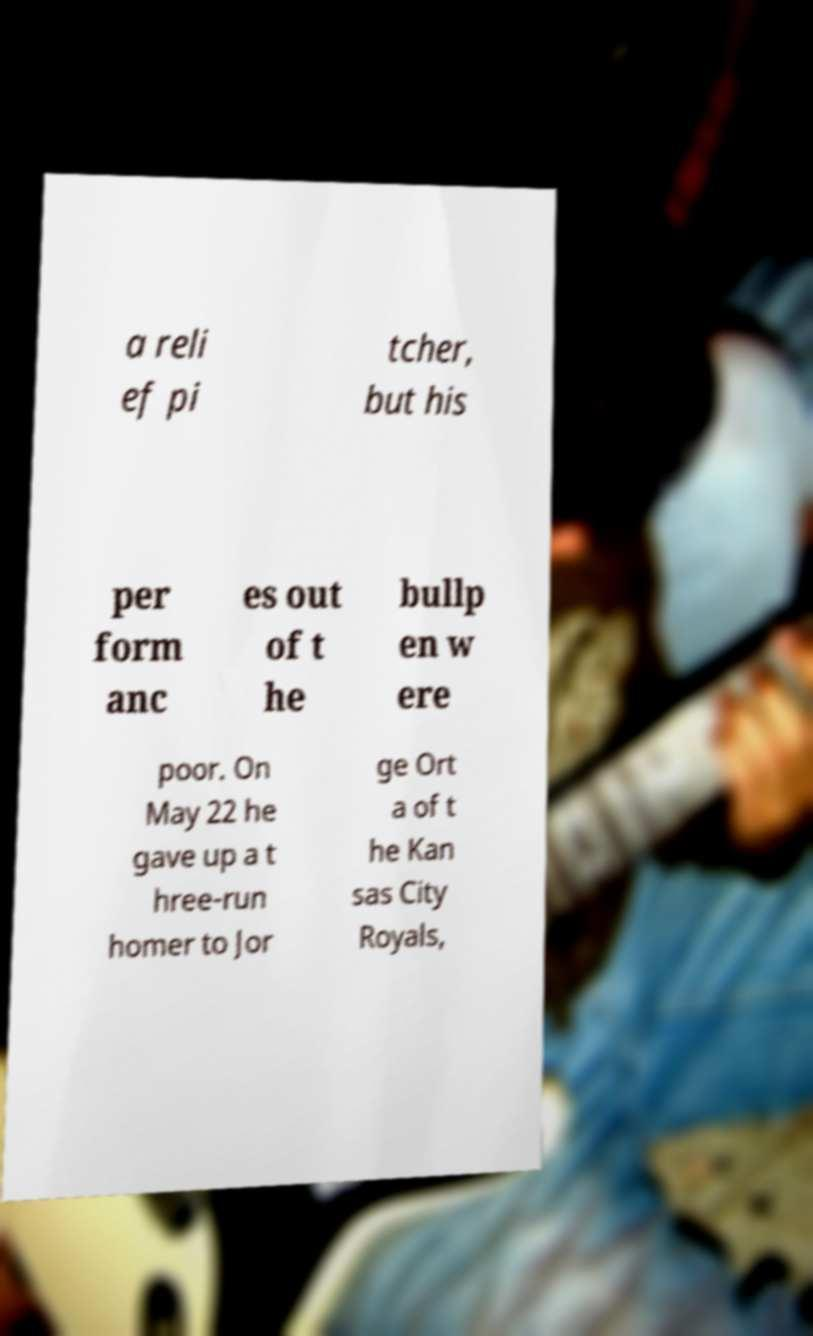Can you accurately transcribe the text from the provided image for me? a reli ef pi tcher, but his per form anc es out of t he bullp en w ere poor. On May 22 he gave up a t hree-run homer to Jor ge Ort a of t he Kan sas City Royals, 